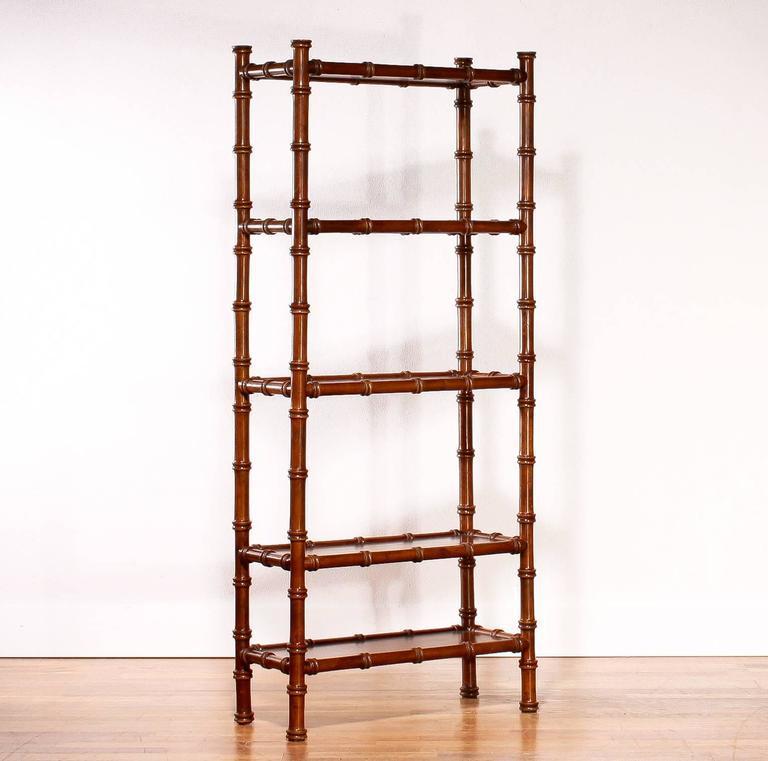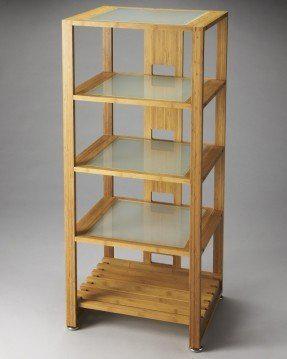The first image is the image on the left, the second image is the image on the right. Evaluate the accuracy of this statement regarding the images: "Two shelves are the same overall shape and have the same number of shelves, but one is made of bamboo while the other is finished wood.". Is it true? Answer yes or no. Yes. The first image is the image on the left, the second image is the image on the right. Assess this claim about the two images: "Left image shows a blond 'traditional' wood shelf unit, and right image shows a rattan shelf unit.". Correct or not? Answer yes or no. No. 